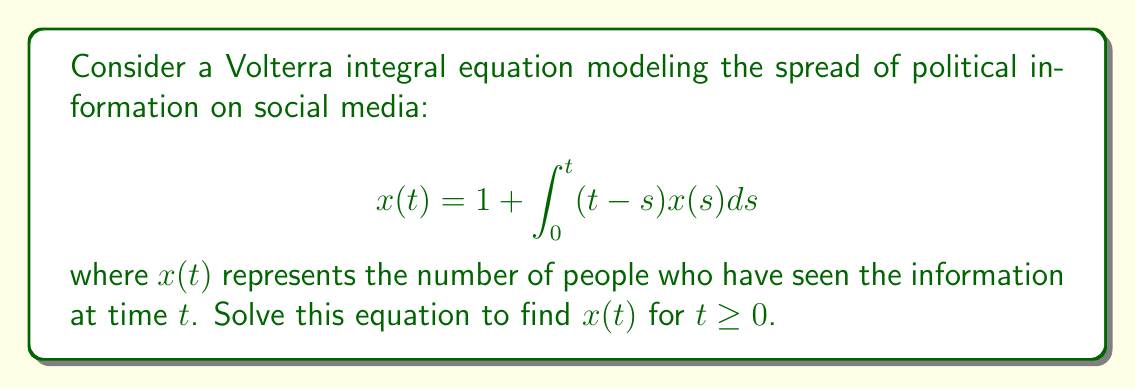What is the answer to this math problem? Let's solve this step-by-step:

1) First, we recognize this as a Volterra integral equation of the second kind.

2) To solve this, we can use the method of successive approximations (Picard iteration).

3) Let's start with the initial approximation $x_0(t) = 1$ (the constant term in the equation).

4) Now, we iterate:

   $x_1(t) = 1 + \int_0^t (t-s)x_0(s)ds = 1 + \int_0^t (t-s)ds = 1 + [ts - \frac{s^2}{2}]_0^t = 1 + \frac{t^2}{2}$

   $x_2(t) = 1 + \int_0^t (t-s)x_1(s)ds = 1 + \int_0^t (t-s)(1 + \frac{s^2}{2})ds$
           $= 1 + [ts - \frac{s^2}{2}]_0^t + [\frac{ts^3}{2} - \frac{s^4}{8}]_0^t$
           $= 1 + \frac{t^2}{2} + \frac{t^4}{8}$

5) We can see a pattern forming. Let's guess that the general solution is:

   $x(t) = 1 + \frac{t^2}{2!} + \frac{t^4}{4!} + \frac{t^6}{6!} + ...$

6) This is the Taylor series for $\cosh(t)$ around $t=0$.

7) We can verify this solution by substituting it back into the original equation:

   $\cosh(t) = 1 + \int_0^t (t-s)\cosh(s)ds$

   The right-hand side simplifies to $\cosh(t)$, confirming our solution.

Therefore, the solution to the Volterra integral equation is $x(t) = \cosh(t)$.
Answer: $x(t) = \cosh(t)$ 